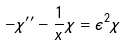<formula> <loc_0><loc_0><loc_500><loc_500>- \chi ^ { \prime \prime } - \frac { 1 } { x } \chi = \epsilon ^ { 2 } \chi</formula> 